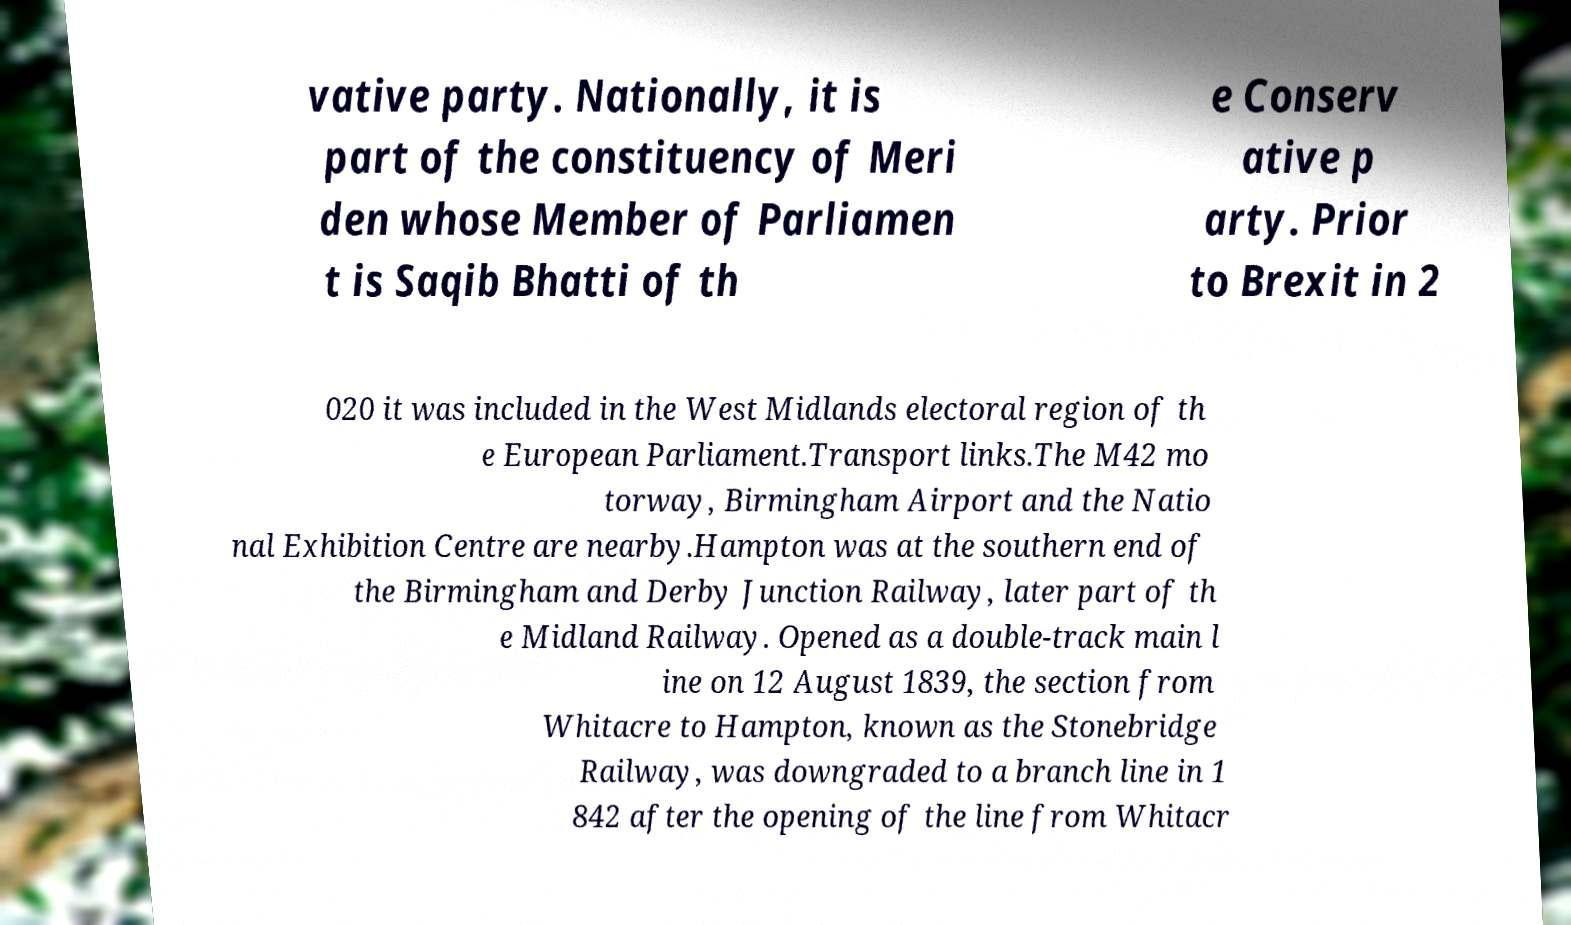For documentation purposes, I need the text within this image transcribed. Could you provide that? vative party. Nationally, it is part of the constituency of Meri den whose Member of Parliamen t is Saqib Bhatti of th e Conserv ative p arty. Prior to Brexit in 2 020 it was included in the West Midlands electoral region of th e European Parliament.Transport links.The M42 mo torway, Birmingham Airport and the Natio nal Exhibition Centre are nearby.Hampton was at the southern end of the Birmingham and Derby Junction Railway, later part of th e Midland Railway. Opened as a double-track main l ine on 12 August 1839, the section from Whitacre to Hampton, known as the Stonebridge Railway, was downgraded to a branch line in 1 842 after the opening of the line from Whitacr 